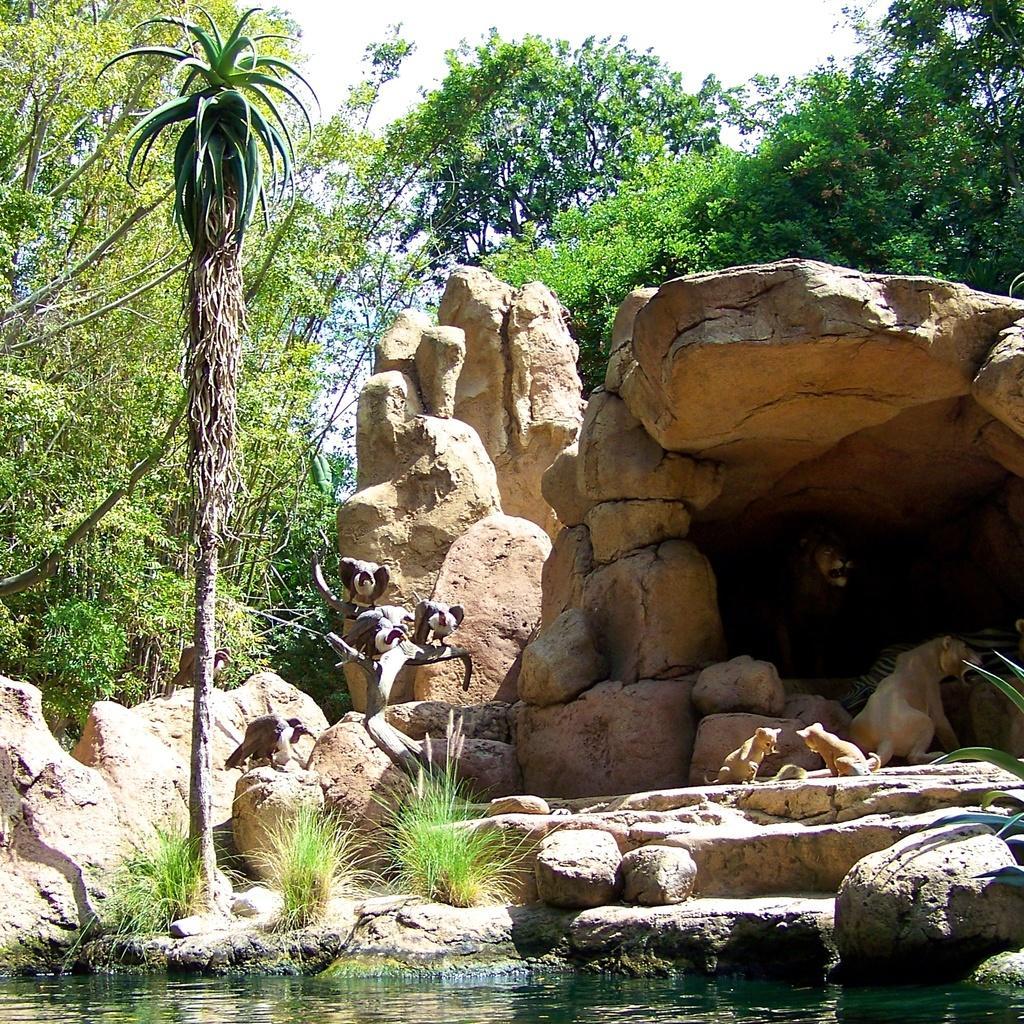Describe this image in one or two sentences. There are animals, stones and water in the foreground area of the image, there are trees, den, stones and the sky in the background. 